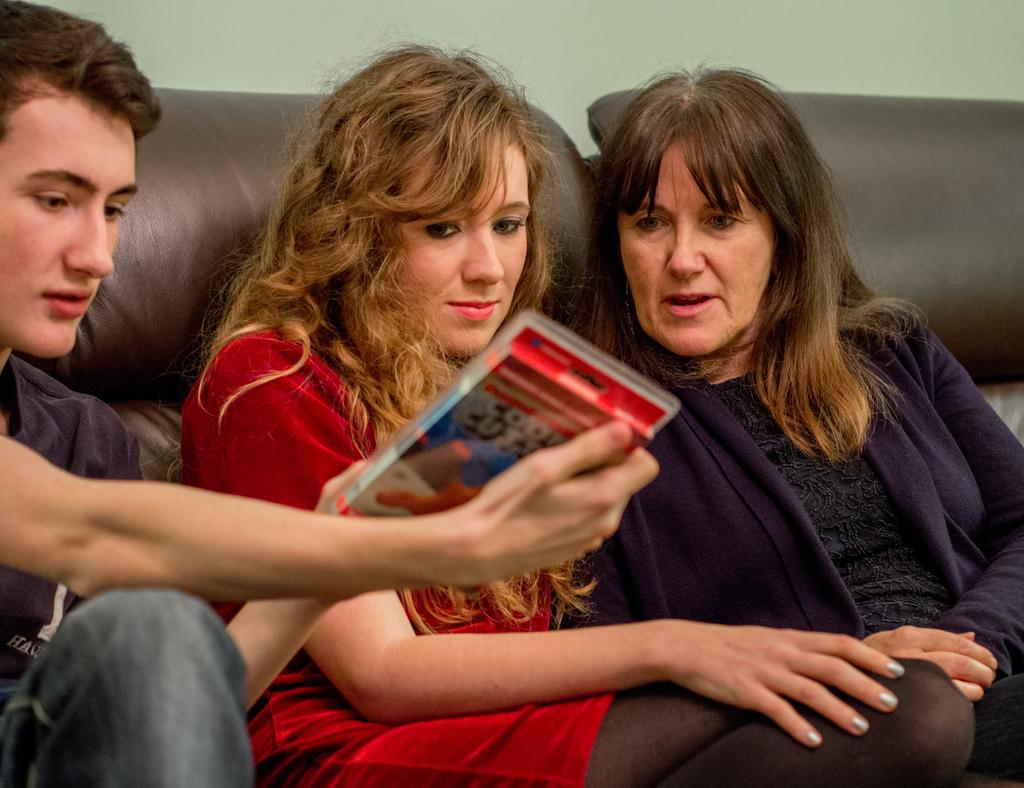How many people are sitting in the image? There are three persons sitting in the image. What is one person holding in the image? One person is holding a packet. What can be seen in the background of the image? There is a couch and a wall in the background of the image. What type of hydrant is visible in the image? There is no hydrant present in the image. 